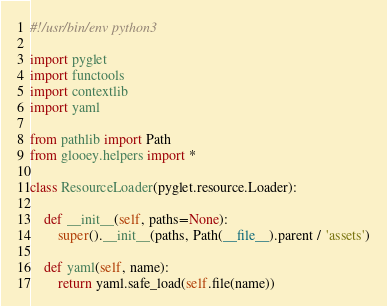<code> <loc_0><loc_0><loc_500><loc_500><_Python_>#!/usr/bin/env python3

import pyglet
import functools
import contextlib
import yaml

from pathlib import Path
from glooey.helpers import *

class ResourceLoader(pyglet.resource.Loader):

    def __init__(self, paths=None):
        super().__init__(paths, Path(__file__).parent / 'assets')

    def yaml(self, name):
        return yaml.safe_load(self.file(name))

</code> 